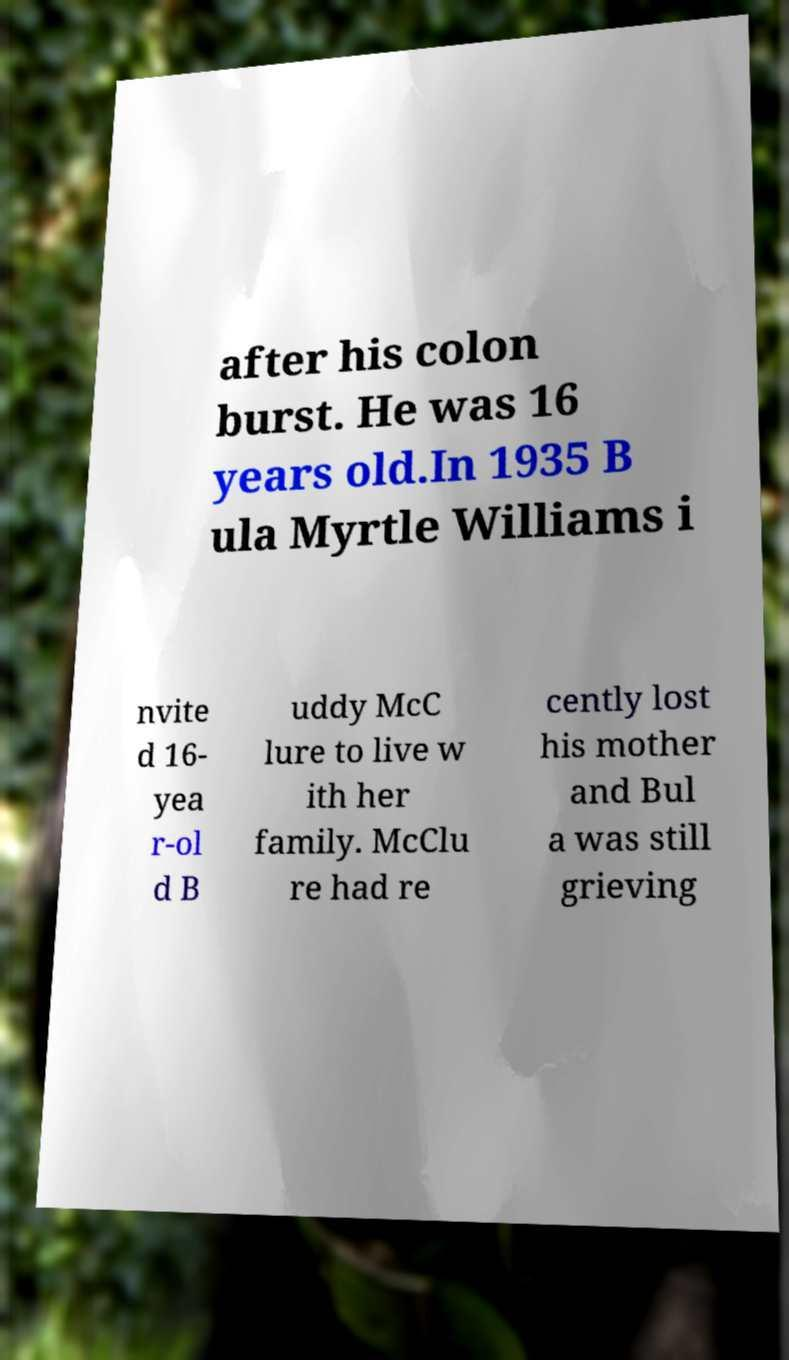There's text embedded in this image that I need extracted. Can you transcribe it verbatim? after his colon burst. He was 16 years old.In 1935 B ula Myrtle Williams i nvite d 16- yea r-ol d B uddy McC lure to live w ith her family. McClu re had re cently lost his mother and Bul a was still grieving 